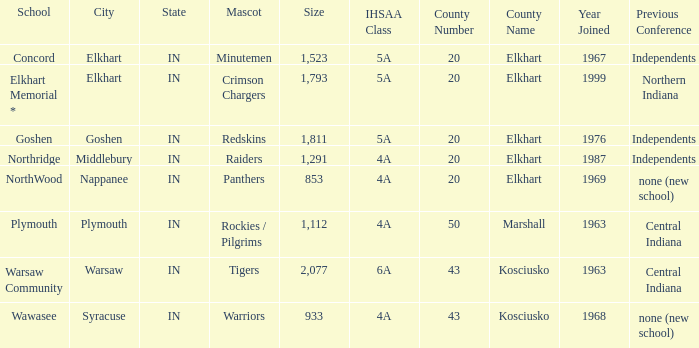What country joined before 1976, with IHSSA class of 5a, and a size larger than 1,112? 20 Elkhart. 